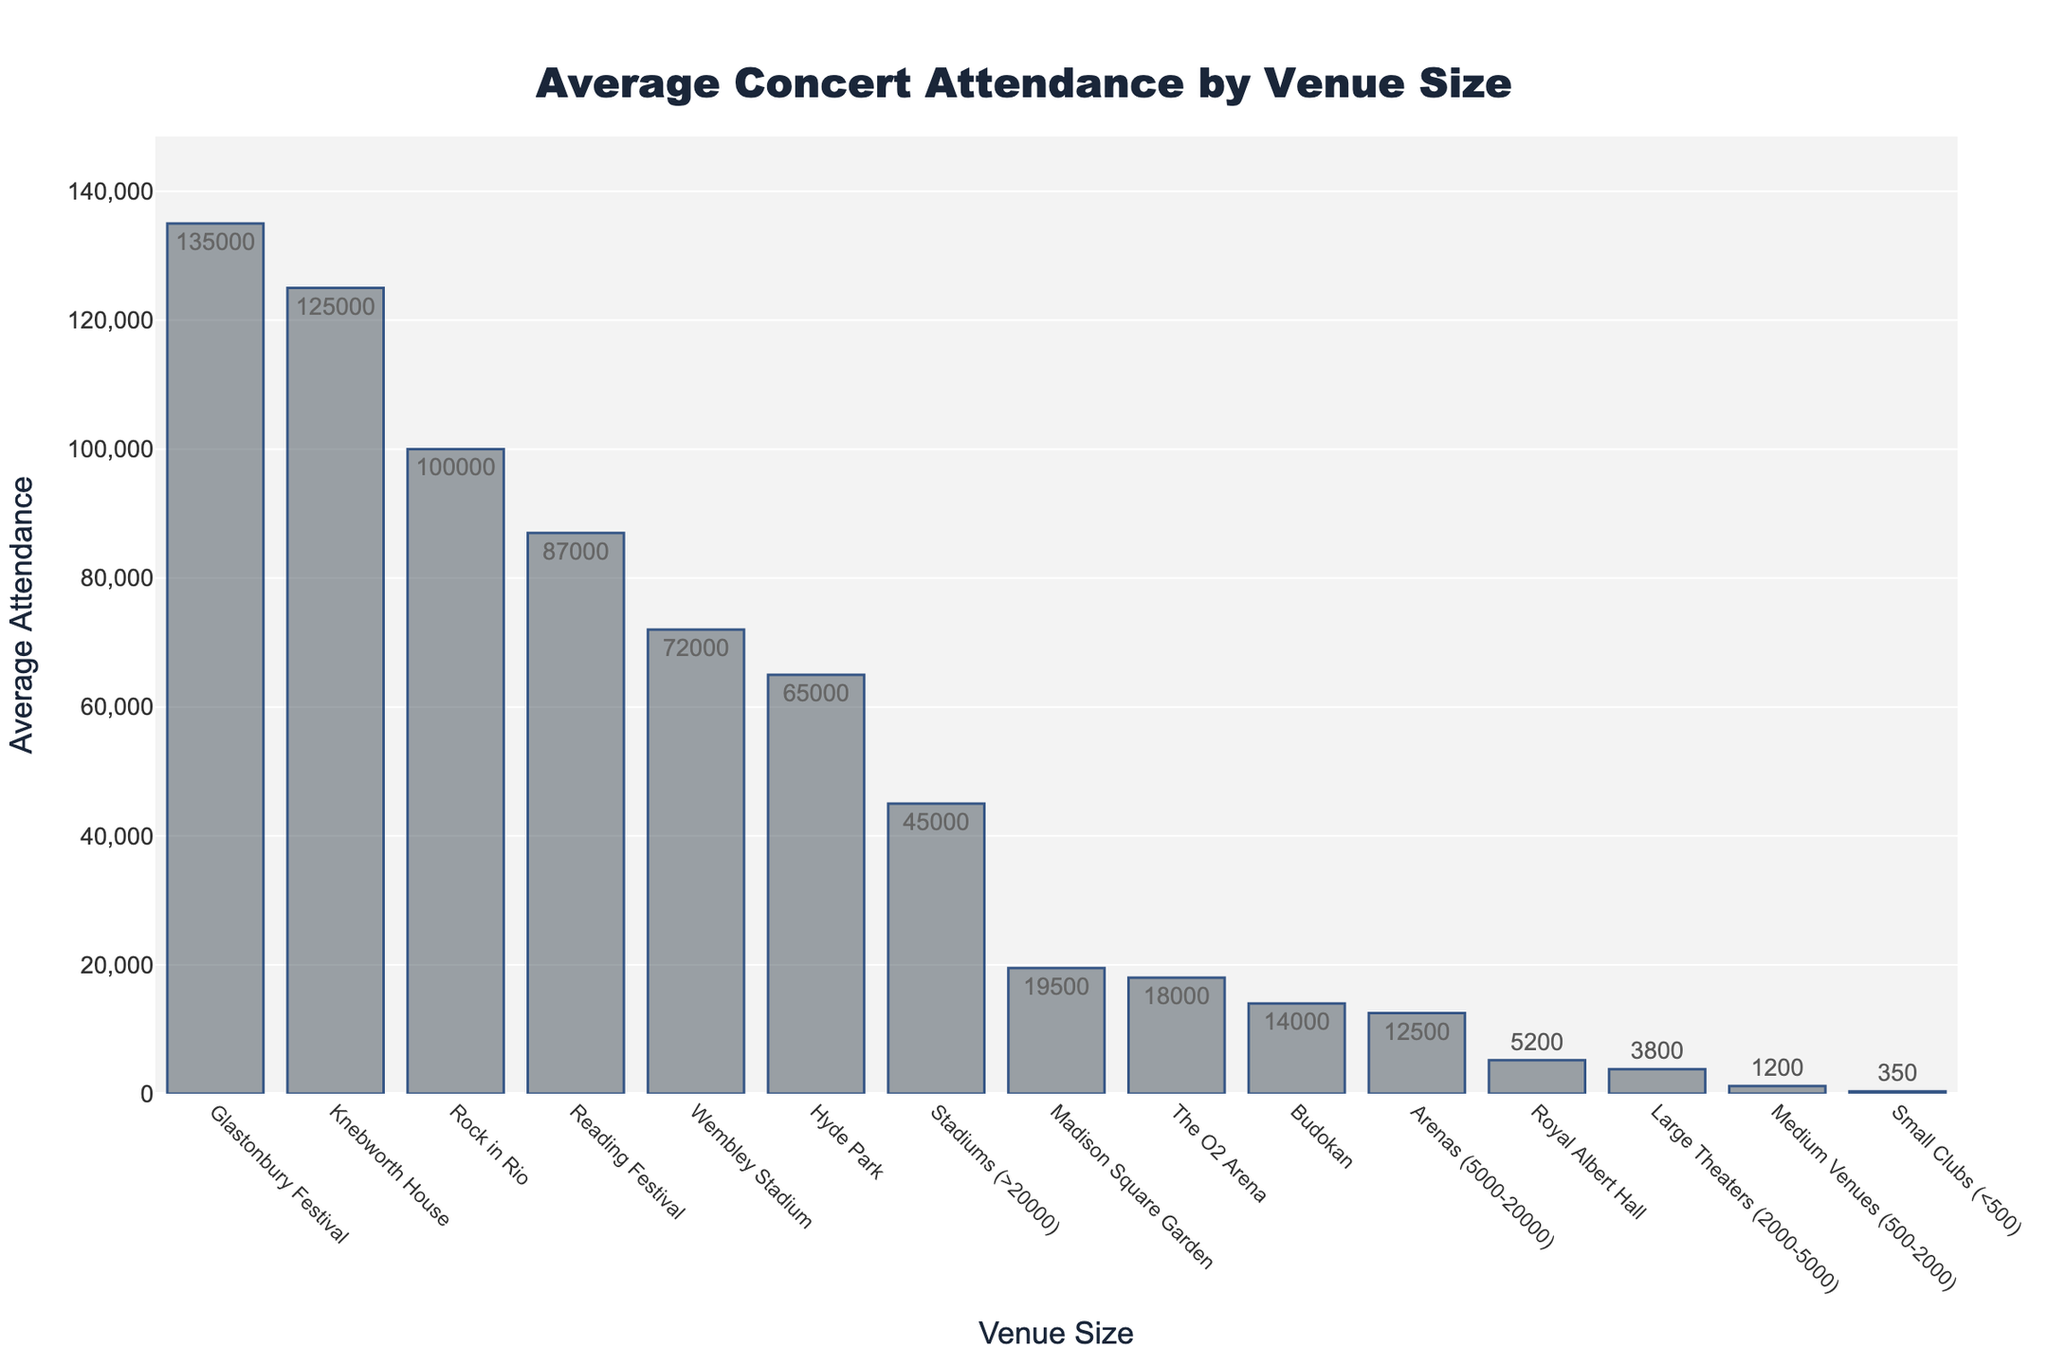Which venue has the highest average attendance? The bar corresponding to "Glastonbury Festival" is the tallest, indicating it has the highest average attendance of 135,000.
Answer: Glastonbury Festival How many concerts were held at medium venues? Hovering over the bar for "Medium Venues" shows a tooltip with the number of concerts as 203.
Answer: 203 What is the difference in average attendance between "Large Theaters" and "Stadiums"? The average attendance for "Large Theaters" is 3,800, and for "Stadiums" it is 45,000. The difference is 45,000 - 3,800.
Answer: 41,200 Which has a higher average attendance: "Madison Square Garden" or "The O2 Arena"? Hovering over the bars indicates that "Madison Square Garden" has an average attendance of 19,500, while "The O2 Arena" has 18,000.
Answer: Madison Square Garden Compare the number of concerts at "Arenas" and "Stadiums". Which is greater? Hovering over the bars shows that "Arenas" had 312 concerts, while "Stadiums" had 98 concerts.
Answer: Arenas What is the combined average attendance of "Hyde Park" and "Reading Festival"? The average attendance for "Hyde Park" is 65,000, and for "Reading Festival" is 87,000. The combined average attendance is 65,000 + 87,000.
Answer: 152,000 How does the average attendance at "Wembley Stadium" compare to "Small Clubs"? Hovering over the bars shows "Wembley Stadium" with 72,000 and "Small Clubs" with 350.
Answer: Wembley Stadium is much higher Which venue has the lowest average attendance? The shortest bar indicates the lowest average attendance, which corresponds to "Small Clubs" at 350.
Answer: Small Clubs What is the relative difference in average attendance between "Budokan" and "Royal Albert Hall"? The average attendance for "Budokan" is 14,000, and for "Royal Albert Hall" it's 5,200. The difference is 14,000 - 5,200, which relative to "Royal Albert Hall" is calculated by (14,000 - 5,200)/5,200 * 100 approx. 169%.
Answer: ~169% What is the sum of the average attendance for "Wembley Stadium" and "Glastonbury Festival"? The average attendance for "Wembley Stadium" is 72,000, and for "Glastonbury Festival" it is 135,000. The sum is 72,000 + 135,000.
Answer: 207,000 